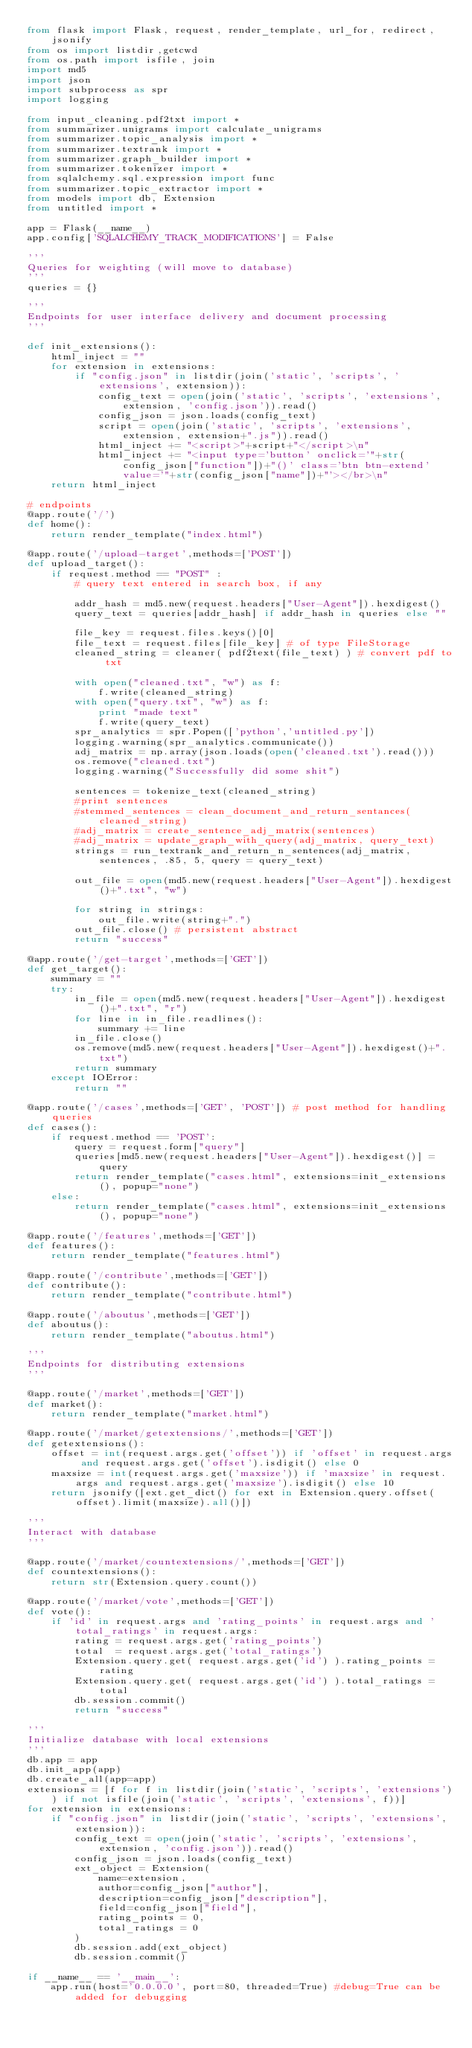Convert code to text. <code><loc_0><loc_0><loc_500><loc_500><_Python_>from flask import Flask, request, render_template, url_for, redirect, jsonify
from os import listdir,getcwd
from os.path import isfile, join
import md5
import json
import subprocess as spr
import logging

from input_cleaning.pdf2txt import *
from summarizer.unigrams import calculate_unigrams
from summarizer.topic_analysis import *
from summarizer.textrank import *
from summarizer.graph_builder import *
from summarizer.tokenizer import *
from sqlalchemy.sql.expression import func
from summarizer.topic_extractor import *
from models import db, Extension
from untitled import * 

app = Flask(__name__)
app.config['SQLALCHEMY_TRACK_MODIFICATIONS'] = False

'''
Queries for weighting (will move to database)
'''
queries = {}

'''
Endpoints for user interface delivery and document processing
'''

def init_extensions():
    html_inject = ""
    for extension in extensions:
        if "config.json" in listdir(join('static', 'scripts', 'extensions', extension)):
            config_text = open(join('static', 'scripts', 'extensions', extension, 'config.json')).read()
            config_json = json.loads(config_text)
            script = open(join('static', 'scripts', 'extensions', extension, extension+".js")).read()
            html_inject += "<script>"+script+"</script>\n"
            html_inject += "<input type='button' onclick='"+str(config_json["function"])+"()' class='btn btn-extend' value='"+str(config_json["name"])+"'></br>\n"
    return html_inject

# endpoints
@app.route('/')
def home():
    return render_template("index.html")

@app.route('/upload-target',methods=['POST'])
def upload_target():
    if request.method == "POST" :
        # query text entered in search box, if any

        addr_hash = md5.new(request.headers["User-Agent"]).hexdigest()
        query_text = queries[addr_hash] if addr_hash in queries else ""
        
        file_key = request.files.keys()[0]
        file_text = request.files[file_key] # of type FileStorage
        cleaned_string = cleaner( pdf2text(file_text) ) # convert pdf to txt
        
        with open("cleaned.txt", "w") as f:
            f.write(cleaned_string)
        with open("query.txt", "w") as f:
            print "made text"
            f.write(query_text)
        spr_analytics = spr.Popen(['python','untitled.py'])
        logging.warning(spr_analytics.communicate())
        adj_matrix = np.array(json.loads(open('cleaned.txt').read()))
        os.remove("cleaned.txt")
        logging.warning("Successfully did some shit")

        sentences = tokenize_text(cleaned_string)
        #print sentences
        #stemmed_sentences = clean_document_and_return_sentances(cleaned_string)
        #adj_matrix = create_sentence_adj_matrix(sentences)
        #adj_matrix = update_graph_with_query(adj_matrix, query_text)
        strings = run_textrank_and_return_n_sentences(adj_matrix, sentences, .85, 5, query = query_text)
        
        out_file = open(md5.new(request.headers["User-Agent"]).hexdigest()+".txt", "w")

        for string in strings:
            out_file.write(string+".")
        out_file.close() # persistent abstract
        return "success"

@app.route('/get-target',methods=['GET'])
def get_target():
    summary = ""
    try:
        in_file = open(md5.new(request.headers["User-Agent"]).hexdigest()+".txt", "r")
        for line in in_file.readlines():
            summary += line
        in_file.close()
        os.remove(md5.new(request.headers["User-Agent"]).hexdigest()+".txt")
        return summary
    except IOError:
        return ""

@app.route('/cases',methods=['GET', 'POST']) # post method for handling queries
def cases():
    if request.method == 'POST':
        query = request.form["query"]
        queries[md5.new(request.headers["User-Agent"]).hexdigest()] = query
        return render_template("cases.html", extensions=init_extensions(), popup="none")
    else:
        return render_template("cases.html", extensions=init_extensions(), popup="none")

@app.route('/features',methods=['GET'])
def features():
    return render_template("features.html")

@app.route('/contribute',methods=['GET'])
def contribute():
    return render_template("contribute.html")

@app.route('/aboutus',methods=['GET'])
def aboutus():
    return render_template("aboutus.html")

'''
Endpoints for distributing extensions
'''

@app.route('/market',methods=['GET'])
def market():
    return render_template("market.html")

@app.route('/market/getextensions/',methods=['GET'])
def getextensions():
    offset = int(request.args.get('offset')) if 'offset' in request.args and request.args.get('offset').isdigit() else 0
    maxsize = int(request.args.get('maxsize')) if 'maxsize' in request.args and request.args.get('maxsize').isdigit() else 10
    return jsonify([ext.get_dict() for ext in Extension.query.offset(offset).limit(maxsize).all()])

'''
Interact with database
'''

@app.route('/market/countextensions/',methods=['GET'])
def countextensions():
    return str(Extension.query.count())

@app.route('/market/vote',methods=['GET'])
def vote():
    if 'id' in request.args and 'rating_points' in request.args and 'total_ratings' in request.args:
        rating = request.args.get('rating_points')
        total  = request.args.get('total_ratings')
        Extension.query.get( request.args.get('id') ).rating_points = rating
        Extension.query.get( request.args.get('id') ).total_ratings = total
        db.session.commit()
        return "success"

'''
Initialize database with local extensions
'''
db.app = app
db.init_app(app)
db.create_all(app=app)
extensions = [f for f in listdir(join('static', 'scripts', 'extensions')) if not isfile(join('static', 'scripts', 'extensions', f))]
for extension in extensions:
    if "config.json" in listdir(join('static', 'scripts', 'extensions', extension)):
        config_text = open(join('static', 'scripts', 'extensions', extension, 'config.json')).read()
        config_json = json.loads(config_text)
        ext_object = Extension(
            name=extension,
            author=config_json["author"],
            description=config_json["description"],
            field=config_json["field"],
            rating_points = 0,
            total_ratings = 0
        )
        db.session.add(ext_object)
        db.session.commit() 

if __name__ == '__main__':
    app.run(host='0.0.0.0', port=80, threaded=True) #debug=True can be added for debugging

    
</code> 